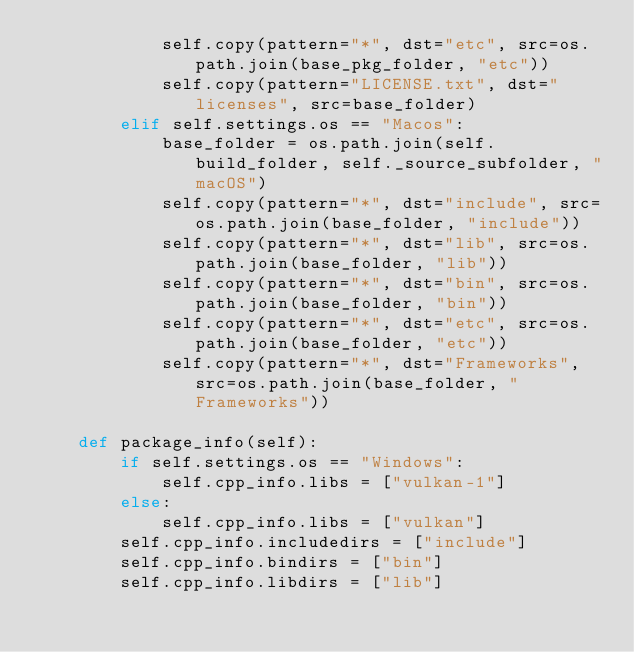Convert code to text. <code><loc_0><loc_0><loc_500><loc_500><_Python_>            self.copy(pattern="*", dst="etc", src=os.path.join(base_pkg_folder, "etc"))
            self.copy(pattern="LICENSE.txt", dst="licenses", src=base_folder)
        elif self.settings.os == "Macos":
            base_folder = os.path.join(self.build_folder, self._source_subfolder, "macOS")
            self.copy(pattern="*", dst="include", src=os.path.join(base_folder, "include"))
            self.copy(pattern="*", dst="lib", src=os.path.join(base_folder, "lib"))
            self.copy(pattern="*", dst="bin", src=os.path.join(base_folder, "bin"))
            self.copy(pattern="*", dst="etc", src=os.path.join(base_folder, "etc"))
            self.copy(pattern="*", dst="Frameworks", src=os.path.join(base_folder, "Frameworks"))

    def package_info(self):
        if self.settings.os == "Windows":
            self.cpp_info.libs = ["vulkan-1"]
        else:
            self.cpp_info.libs = ["vulkan"]
        self.cpp_info.includedirs = ["include"]
        self.cpp_info.bindirs = ["bin"]
        self.cpp_info.libdirs = ["lib"]
</code> 